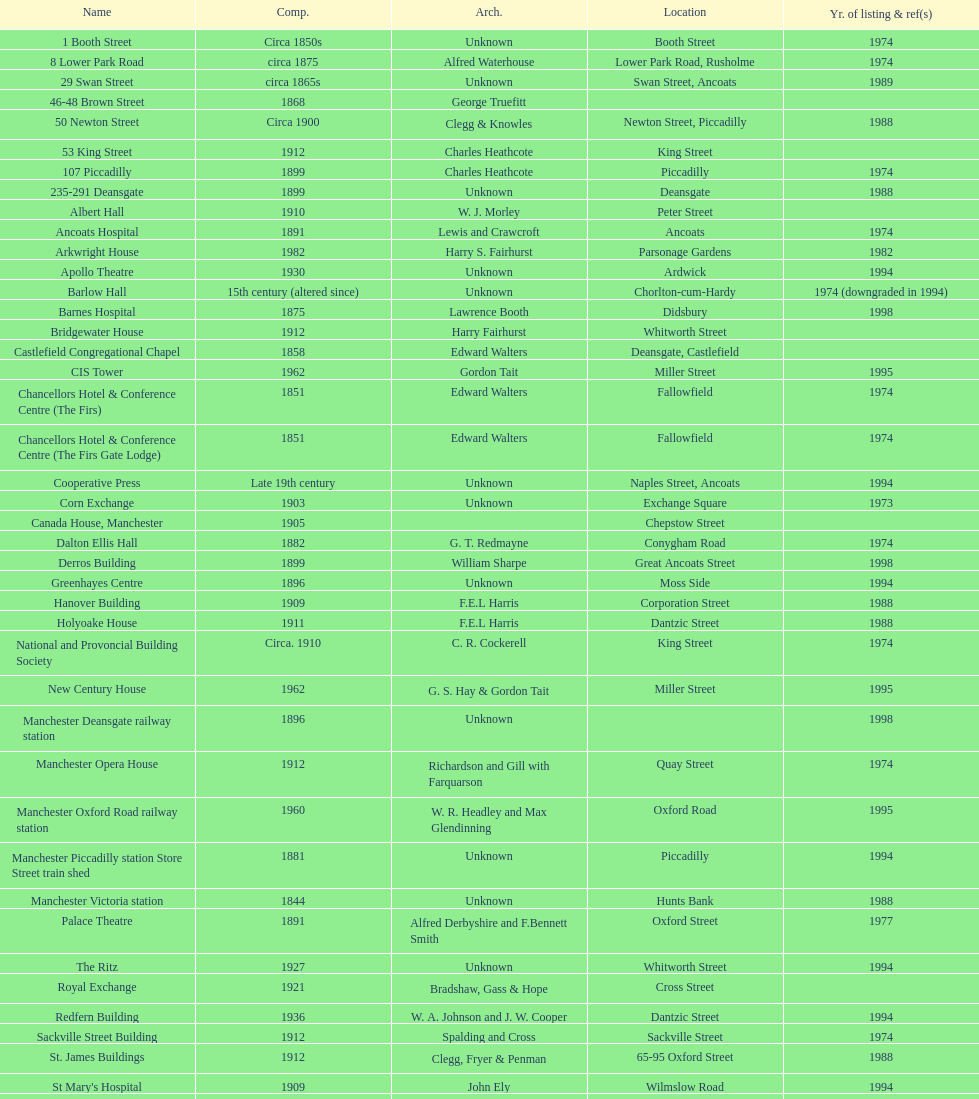How many buildings has the same year of listing as 1974? 15. 